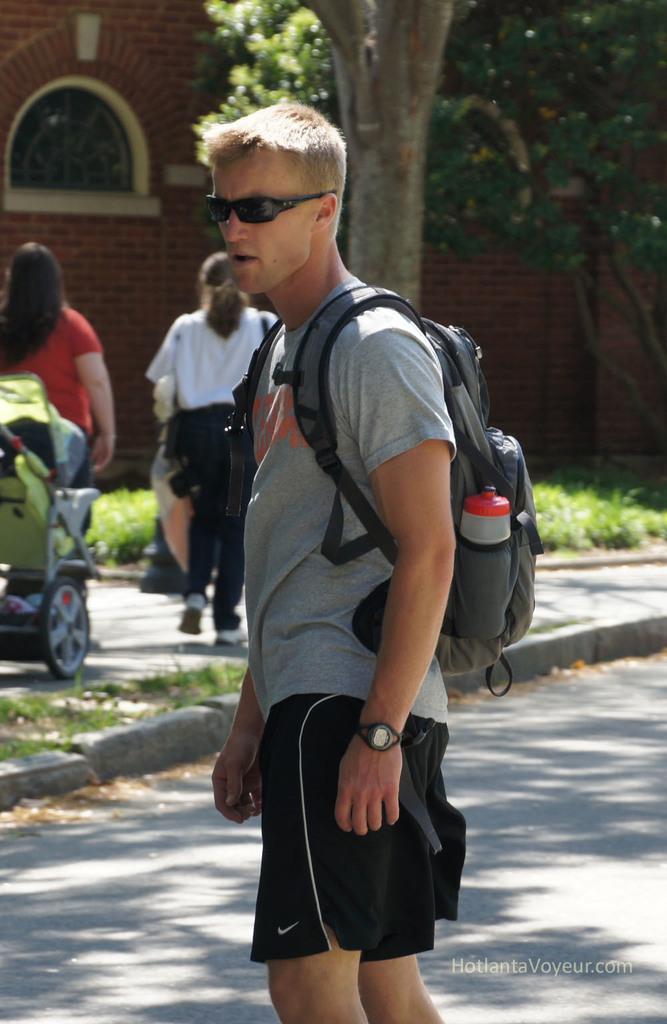How would you summarize this image in a sentence or two? On the background we can see a wall with bricks and a window. This is a tree and these are plants. We can see persons standing and walking on the road. This is a cartwheel. on the road we can see one man wearing a backpack and there is a bottle in the bag. He wore goggles. 